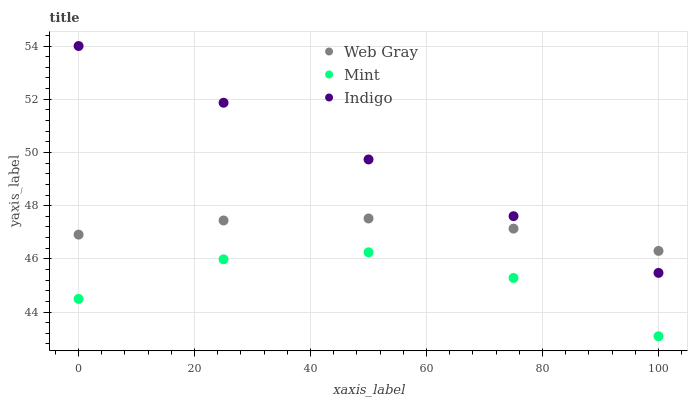Does Mint have the minimum area under the curve?
Answer yes or no. Yes. Does Indigo have the maximum area under the curve?
Answer yes or no. Yes. Does Web Gray have the minimum area under the curve?
Answer yes or no. No. Does Web Gray have the maximum area under the curve?
Answer yes or no. No. Is Indigo the smoothest?
Answer yes or no. Yes. Is Mint the roughest?
Answer yes or no. Yes. Is Web Gray the smoothest?
Answer yes or no. No. Is Web Gray the roughest?
Answer yes or no. No. Does Mint have the lowest value?
Answer yes or no. Yes. Does Web Gray have the lowest value?
Answer yes or no. No. Does Indigo have the highest value?
Answer yes or no. Yes. Does Web Gray have the highest value?
Answer yes or no. No. Is Mint less than Indigo?
Answer yes or no. Yes. Is Indigo greater than Mint?
Answer yes or no. Yes. Does Web Gray intersect Indigo?
Answer yes or no. Yes. Is Web Gray less than Indigo?
Answer yes or no. No. Is Web Gray greater than Indigo?
Answer yes or no. No. Does Mint intersect Indigo?
Answer yes or no. No. 